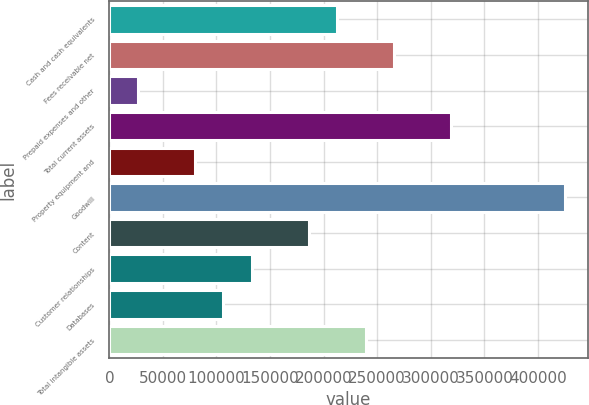Convert chart. <chart><loc_0><loc_0><loc_500><loc_500><bar_chart><fcel>Cash and cash equivalents<fcel>Fees receivable net<fcel>Prepaid expenses and other<fcel>Total current assets<fcel>Property equipment and<fcel>Goodwill<fcel>Content<fcel>Customer relationships<fcel>Databases<fcel>Total intangible assets<nl><fcel>212750<fcel>265904<fcel>26711<fcel>319058<fcel>79865<fcel>425366<fcel>186173<fcel>133019<fcel>106442<fcel>239327<nl></chart> 